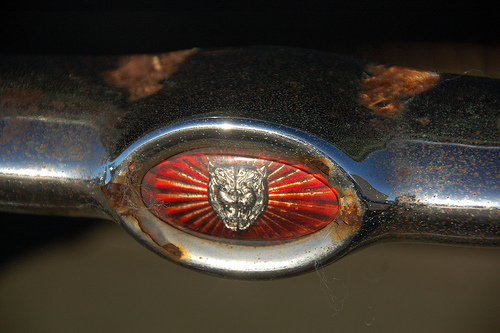<image>
Can you confirm if the rust is behind the bumper? No. The rust is not behind the bumper. From this viewpoint, the rust appears to be positioned elsewhere in the scene. 